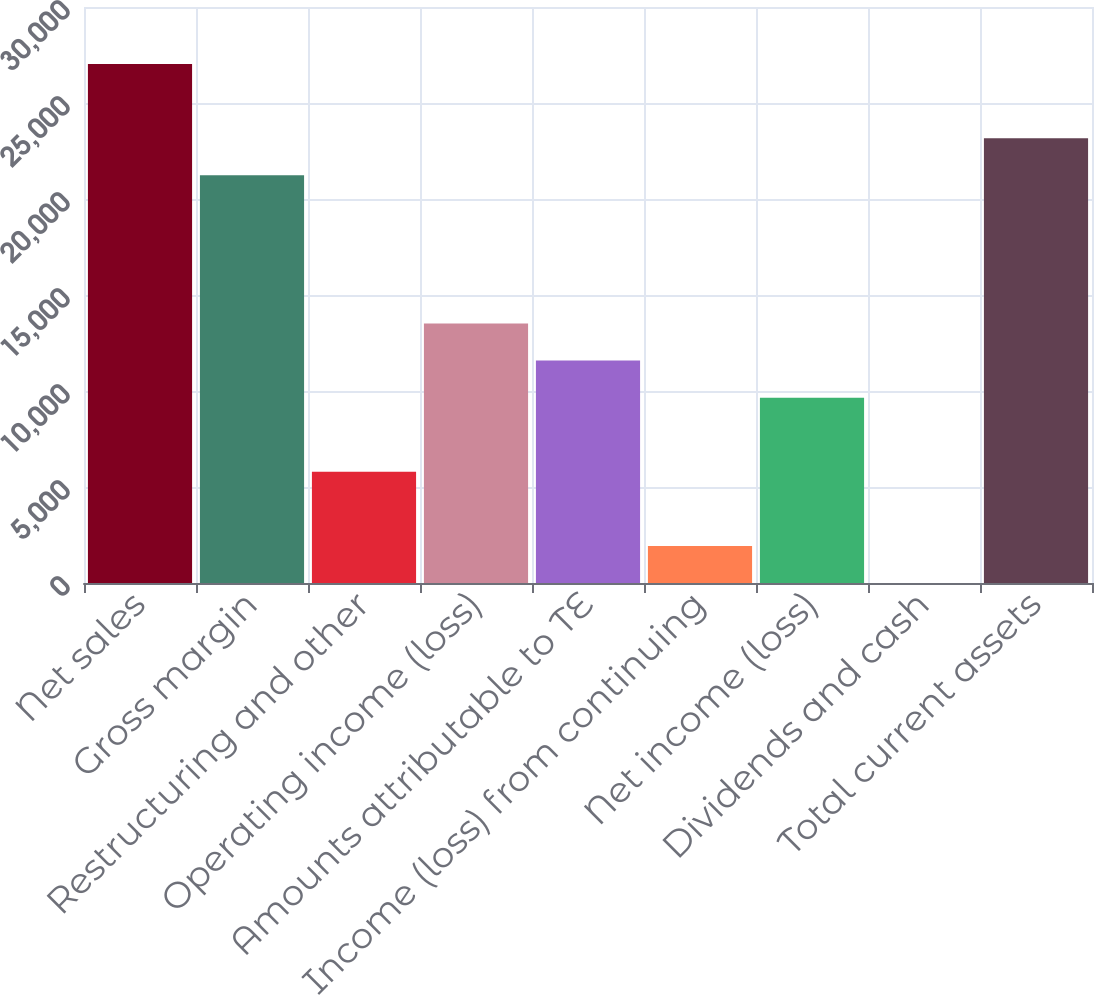Convert chart. <chart><loc_0><loc_0><loc_500><loc_500><bar_chart><fcel>Net sales<fcel>Gross margin<fcel>Restructuring and other<fcel>Operating income (loss)<fcel>Amounts attributable to TE<fcel>Income (loss) from continuing<fcel>Net income (loss)<fcel>Dividends and cash<fcel>Total current assets<nl><fcel>27028.1<fcel>21236.5<fcel>5792.34<fcel>13514.4<fcel>11583.9<fcel>1931.3<fcel>9653.38<fcel>0.78<fcel>23167<nl></chart> 